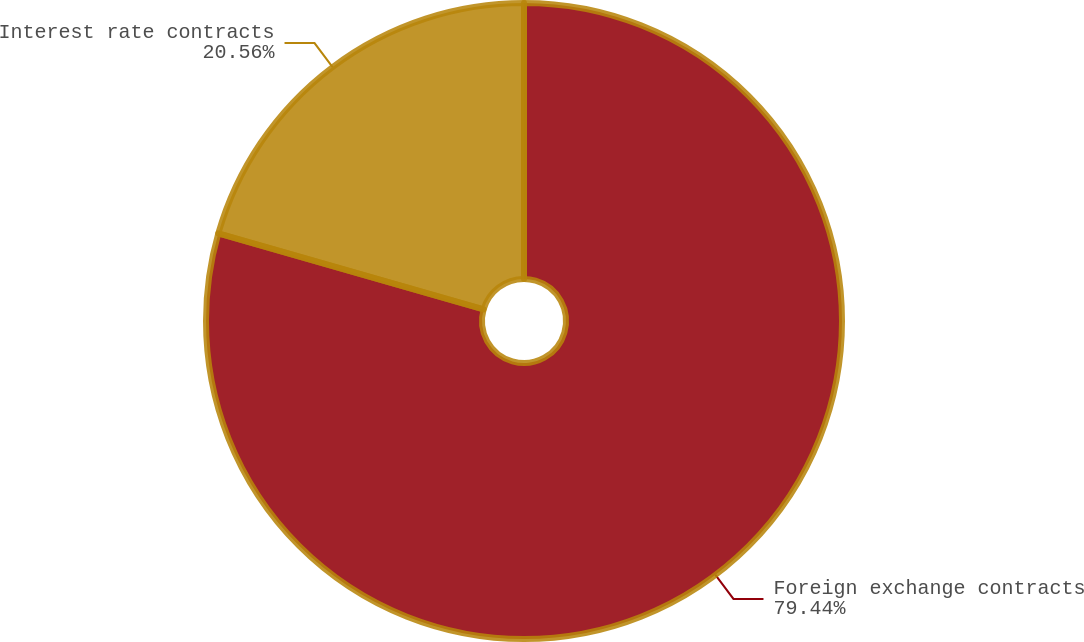<chart> <loc_0><loc_0><loc_500><loc_500><pie_chart><fcel>Foreign exchange contracts<fcel>Interest rate contracts<nl><fcel>79.44%<fcel>20.56%<nl></chart> 